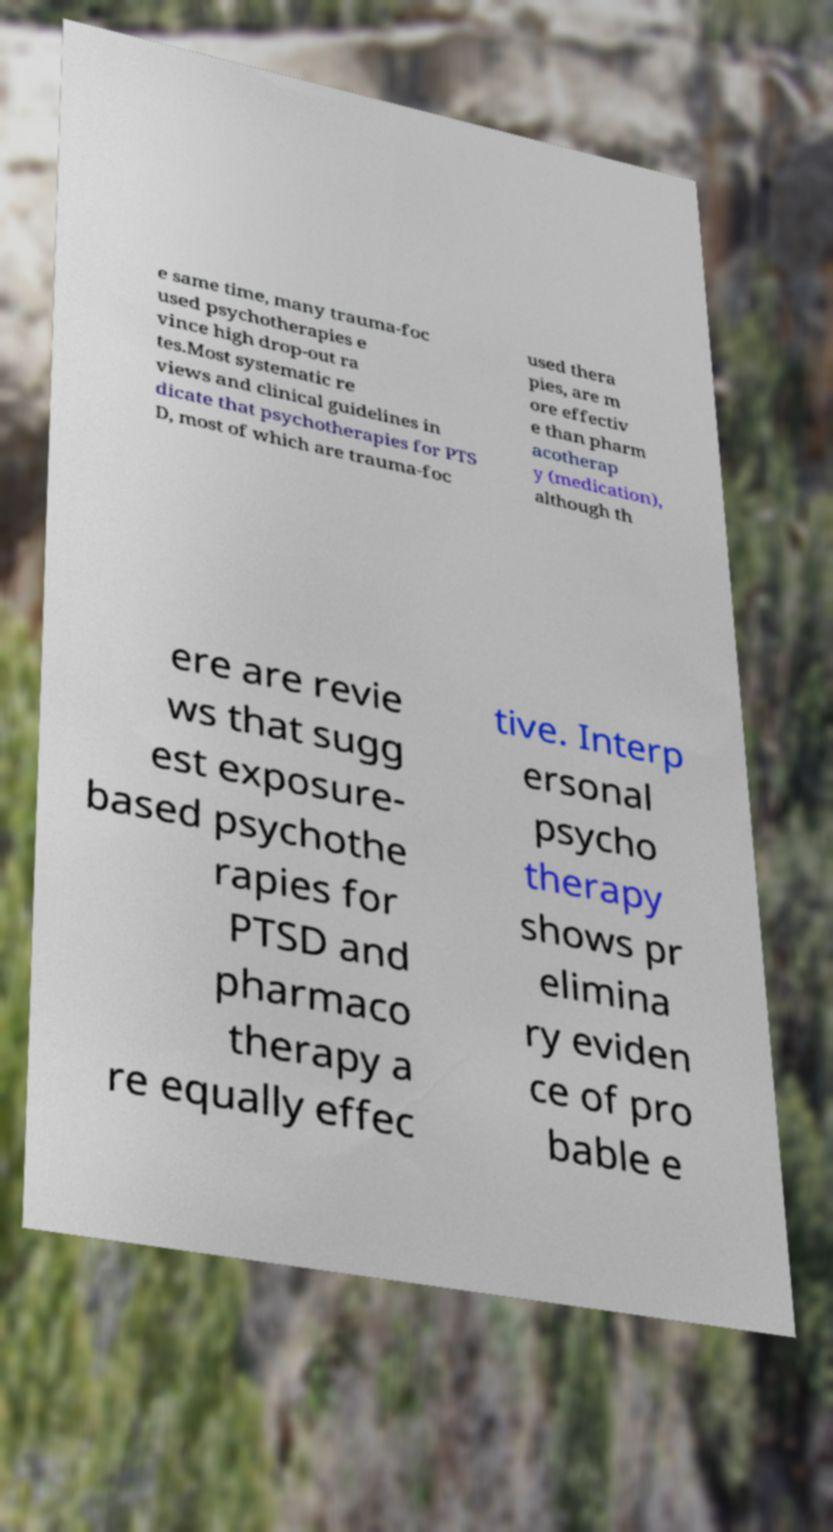Could you extract and type out the text from this image? e same time, many trauma-foc used psychotherapies e vince high drop-out ra tes.Most systematic re views and clinical guidelines in dicate that psychotherapies for PTS D, most of which are trauma-foc used thera pies, are m ore effectiv e than pharm acotherap y (medication), although th ere are revie ws that sugg est exposure- based psychothe rapies for PTSD and pharmaco therapy a re equally effec tive. Interp ersonal psycho therapy shows pr elimina ry eviden ce of pro bable e 